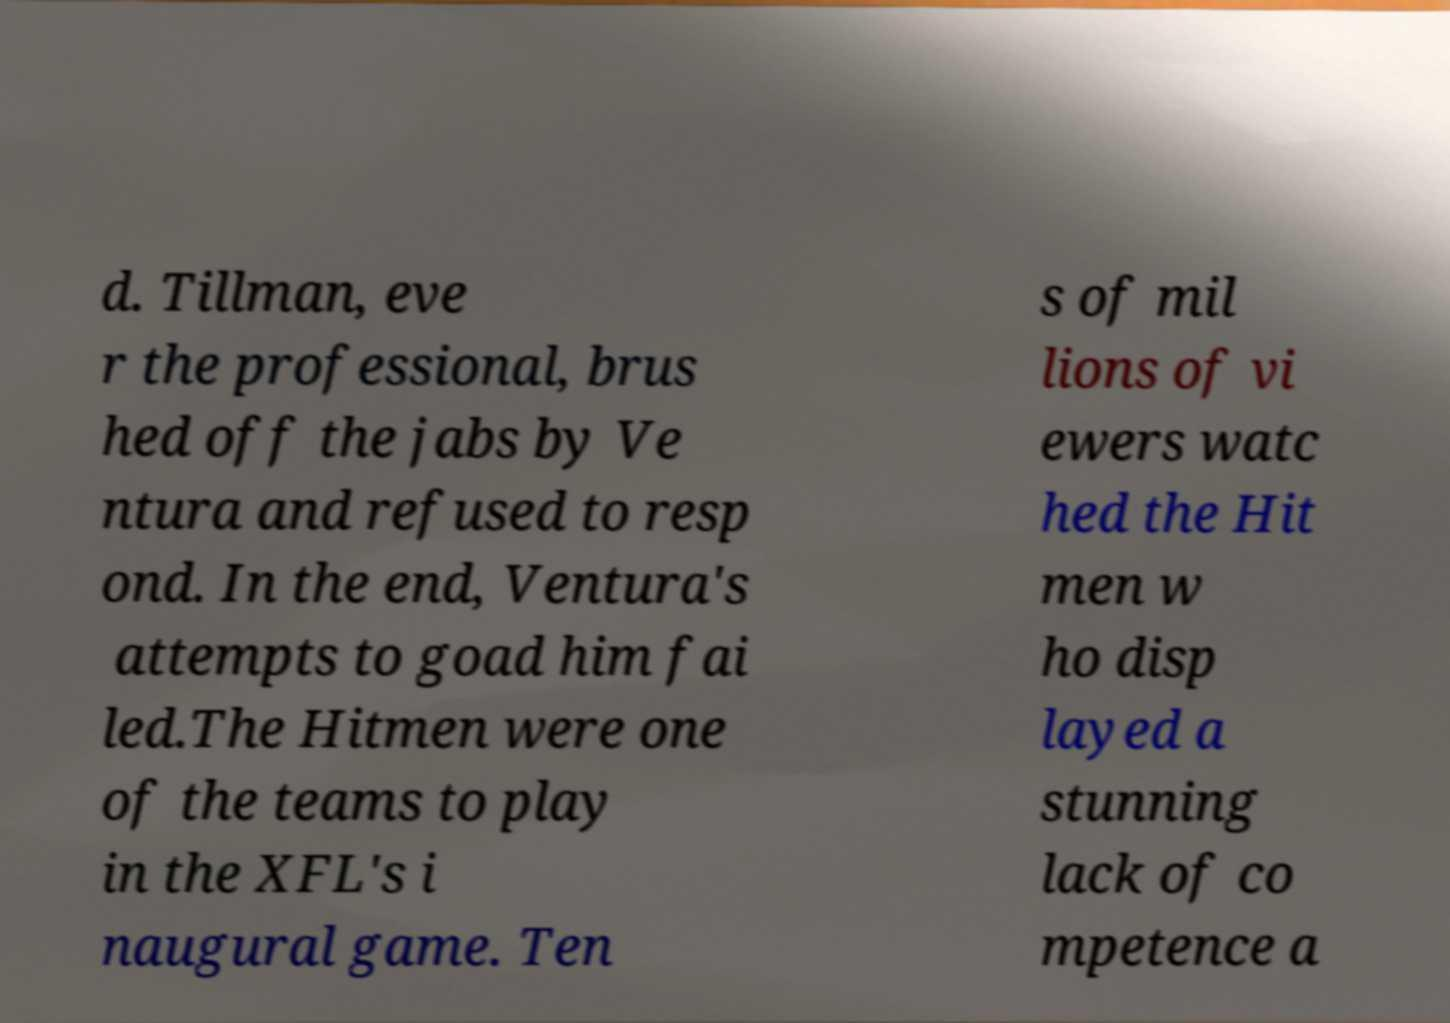Please identify and transcribe the text found in this image. d. Tillman, eve r the professional, brus hed off the jabs by Ve ntura and refused to resp ond. In the end, Ventura's attempts to goad him fai led.The Hitmen were one of the teams to play in the XFL's i naugural game. Ten s of mil lions of vi ewers watc hed the Hit men w ho disp layed a stunning lack of co mpetence a 